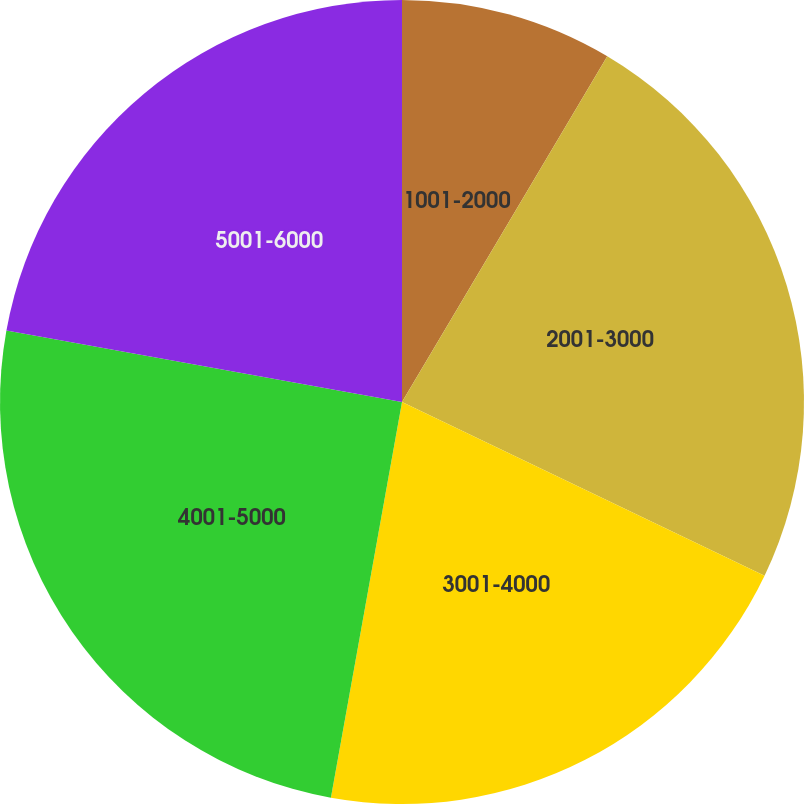<chart> <loc_0><loc_0><loc_500><loc_500><pie_chart><fcel>1001-2000<fcel>2001-3000<fcel>3001-4000<fcel>4001-5000<fcel>5001-6000<nl><fcel>8.53%<fcel>23.58%<fcel>20.72%<fcel>25.02%<fcel>22.15%<nl></chart> 